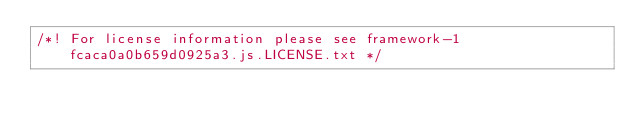<code> <loc_0><loc_0><loc_500><loc_500><_JavaScript_>/*! For license information please see framework-1fcaca0a0b659d0925a3.js.LICENSE.txt */</code> 